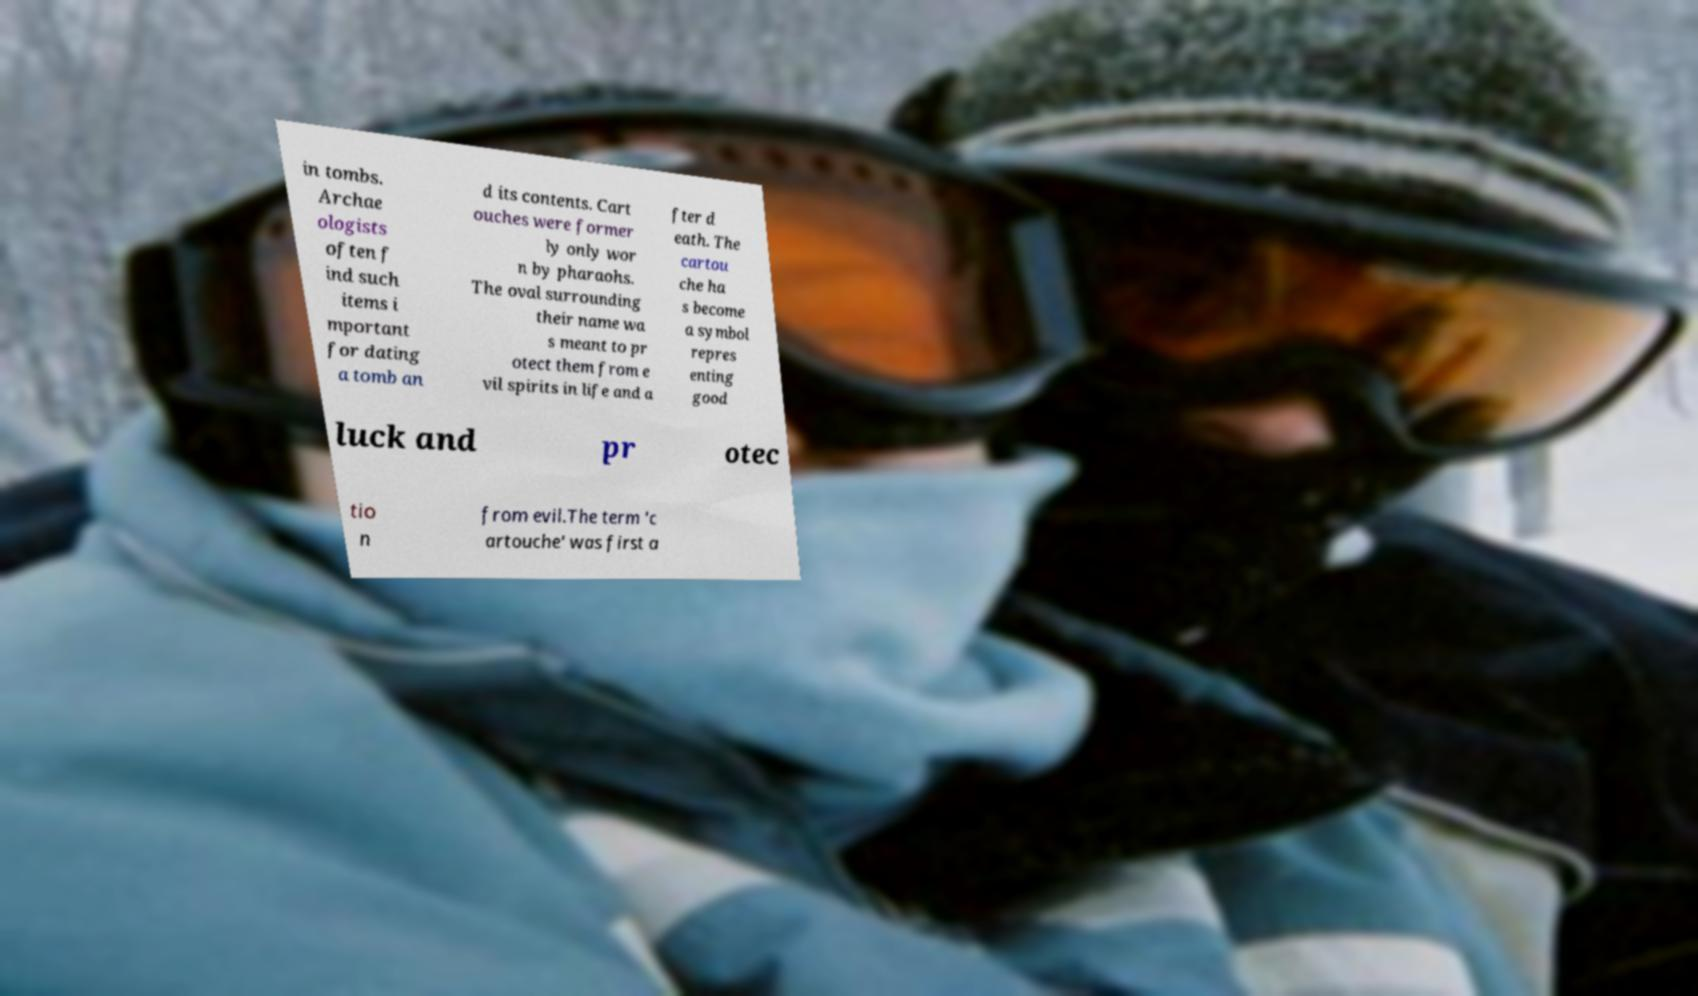There's text embedded in this image that I need extracted. Can you transcribe it verbatim? in tombs. Archae ologists often f ind such items i mportant for dating a tomb an d its contents. Cart ouches were former ly only wor n by pharaohs. The oval surrounding their name wa s meant to pr otect them from e vil spirits in life and a fter d eath. The cartou che ha s become a symbol repres enting good luck and pr otec tio n from evil.The term 'c artouche' was first a 